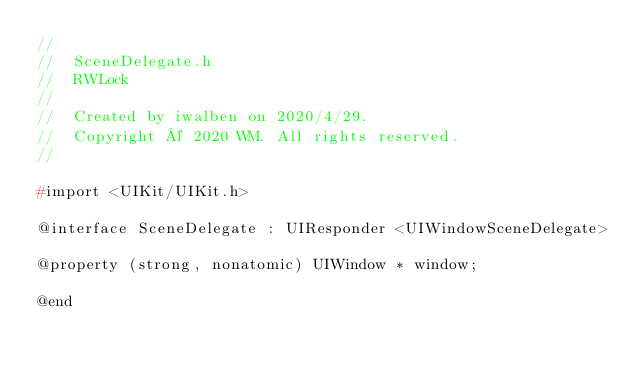Convert code to text. <code><loc_0><loc_0><loc_500><loc_500><_C_>//
//  SceneDelegate.h
//  RWLock
//
//  Created by iwalben on 2020/4/29.
//  Copyright © 2020 WM. All rights reserved.
//

#import <UIKit/UIKit.h>

@interface SceneDelegate : UIResponder <UIWindowSceneDelegate>

@property (strong, nonatomic) UIWindow * window;

@end

</code> 